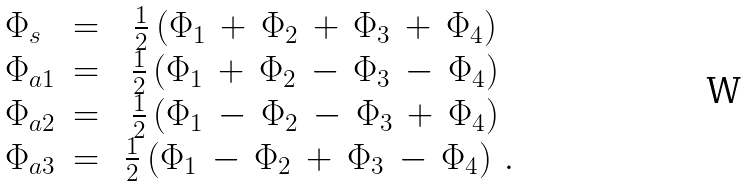<formula> <loc_0><loc_0><loc_500><loc_500>\begin{array} { l c c } \Phi _ { s } & = & \frac { 1 } { 2 } \left ( \Phi _ { 1 } \, + \, \Phi _ { 2 } \, + \, \Phi _ { 3 } \, + \, \Phi _ { 4 } \right ) \\ \Phi _ { a 1 } & = & \frac { 1 } { 2 } \left ( \Phi _ { 1 } \, + \, \Phi _ { 2 } \, - \, \Phi _ { 3 } \, - \, \Phi _ { 4 } \right ) \\ \Phi _ { a 2 } & = & \frac { 1 } { 2 } \left ( \Phi _ { 1 } \, - \, \Phi _ { 2 } \, - \, \Phi _ { 3 } \, + \, \Phi _ { 4 } \right ) \\ \Phi _ { a 3 } & = & \ \frac { 1 } { 2 } \left ( \Phi _ { 1 } \, - \, \Phi _ { 2 } \, + \, \Phi _ { 3 } \, - \, \Phi _ { 4 } \right ) \, . \end{array}</formula> 